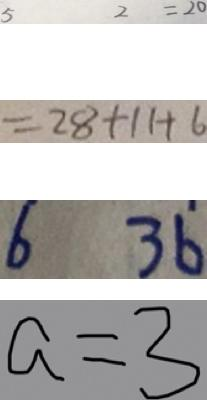<formula> <loc_0><loc_0><loc_500><loc_500>5 2 = 2 0 
 = 2 8 + 1 1 + 6 
 6 3 6 
 a = 3</formula> 